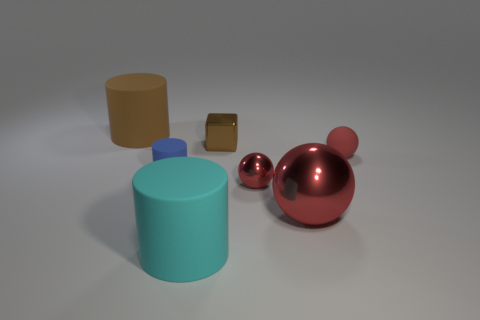What materials do the objects in the image look like they're made of? The objects appear to be rendered with different materials. The tall cylinder and the small blue sphere have a matte finish that suggests they might be made of rubber or plastic. The small cube has a reflective surface indicating it could be metallic. And the larger red spheres have a glossy, reflective surface, which often suggests a smooth, hard material like polished metal or glass. 